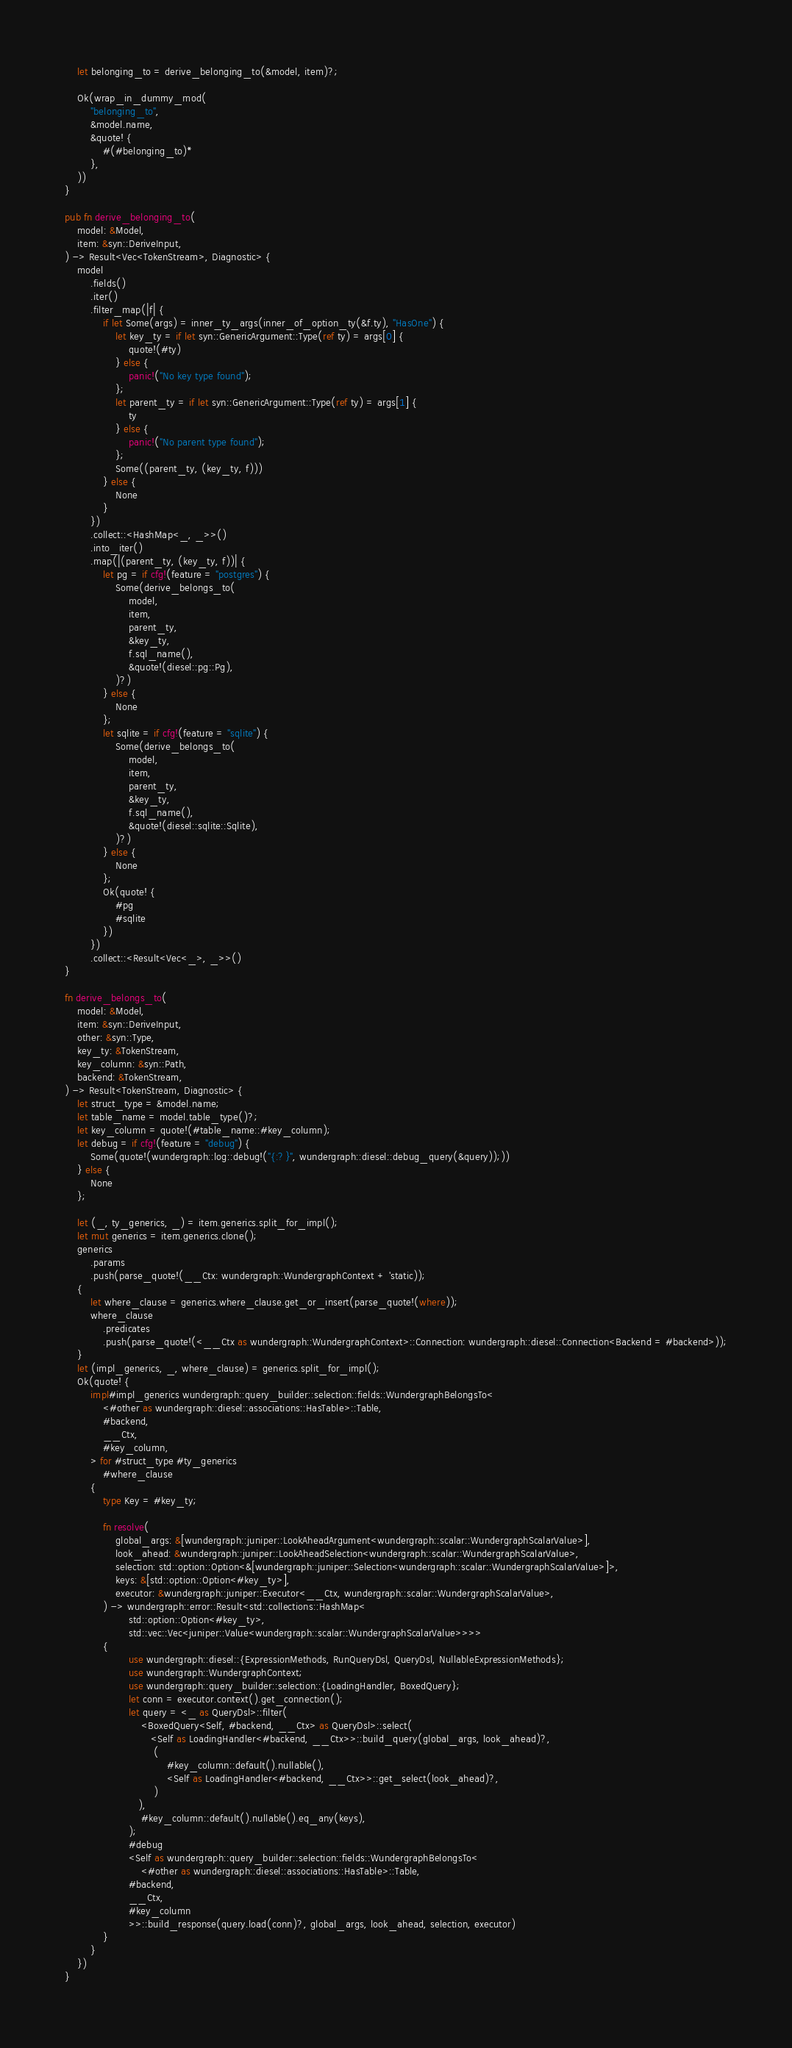Convert code to text. <code><loc_0><loc_0><loc_500><loc_500><_Rust_>    let belonging_to = derive_belonging_to(&model, item)?;

    Ok(wrap_in_dummy_mod(
        "belonging_to",
        &model.name,
        &quote! {
            #(#belonging_to)*
        },
    ))
}

pub fn derive_belonging_to(
    model: &Model,
    item: &syn::DeriveInput,
) -> Result<Vec<TokenStream>, Diagnostic> {
    model
        .fields()
        .iter()
        .filter_map(|f| {
            if let Some(args) = inner_ty_args(inner_of_option_ty(&f.ty), "HasOne") {
                let key_ty = if let syn::GenericArgument::Type(ref ty) = args[0] {
                    quote!(#ty)
                } else {
                    panic!("No key type found");
                };
                let parent_ty = if let syn::GenericArgument::Type(ref ty) = args[1] {
                    ty
                } else {
                    panic!("No parent type found");
                };
                Some((parent_ty, (key_ty, f)))
            } else {
                None
            }
        })
        .collect::<HashMap<_, _>>()
        .into_iter()
        .map(|(parent_ty, (key_ty, f))| {
            let pg = if cfg!(feature = "postgres") {
                Some(derive_belongs_to(
                    model,
                    item,
                    parent_ty,
                    &key_ty,
                    f.sql_name(),
                    &quote!(diesel::pg::Pg),
                )?)
            } else {
                None
            };
            let sqlite = if cfg!(feature = "sqlite") {
                Some(derive_belongs_to(
                    model,
                    item,
                    parent_ty,
                    &key_ty,
                    f.sql_name(),
                    &quote!(diesel::sqlite::Sqlite),
                )?)
            } else {
                None
            };
            Ok(quote! {
                #pg
                #sqlite
            })
        })
        .collect::<Result<Vec<_>, _>>()
}

fn derive_belongs_to(
    model: &Model,
    item: &syn::DeriveInput,
    other: &syn::Type,
    key_ty: &TokenStream,
    key_column: &syn::Path,
    backend: &TokenStream,
) -> Result<TokenStream, Diagnostic> {
    let struct_type = &model.name;
    let table_name = model.table_type()?;
    let key_column = quote!(#table_name::#key_column);
    let debug = if cfg!(feature = "debug") {
        Some(quote!(wundergraph::log::debug!("{:?}", wundergraph::diesel::debug_query(&query));))
    } else {
        None
    };

    let (_, ty_generics, _) = item.generics.split_for_impl();
    let mut generics = item.generics.clone();
    generics
        .params
        .push(parse_quote!(__Ctx: wundergraph::WundergraphContext + 'static));
    {
        let where_clause = generics.where_clause.get_or_insert(parse_quote!(where));
        where_clause
            .predicates
            .push(parse_quote!(<__Ctx as wundergraph::WundergraphContext>::Connection: wundergraph::diesel::Connection<Backend = #backend>));
    }
    let (impl_generics, _, where_clause) = generics.split_for_impl();
    Ok(quote! {
        impl#impl_generics wundergraph::query_builder::selection::fields::WundergraphBelongsTo<
            <#other as wundergraph::diesel::associations::HasTable>::Table,
            #backend,
            __Ctx,
            #key_column,
        > for #struct_type #ty_generics
            #where_clause
        {
            type Key = #key_ty;

            fn resolve(
                global_args: &[wundergraph::juniper::LookAheadArgument<wundergraph::scalar::WundergraphScalarValue>],
                look_ahead: &wundergraph::juniper::LookAheadSelection<wundergraph::scalar::WundergraphScalarValue>,
                selection: std::option::Option<&[wundergraph::juniper::Selection<wundergraph::scalar::WundergraphScalarValue>]>,
                keys: &[std::option::Option<#key_ty>],
                executor: &wundergraph::juniper::Executor<__Ctx, wundergraph::scalar::WundergraphScalarValue>,
            ) -> wundergraph::error::Result<std::collections::HashMap<
                    std::option::Option<#key_ty>,
                    std::vec::Vec<juniper::Value<wundergraph::scalar::WundergraphScalarValue>>>>
            {
                    use wundergraph::diesel::{ExpressionMethods, RunQueryDsl, QueryDsl, NullableExpressionMethods};
                    use wundergraph::WundergraphContext;
                    use wundergraph::query_builder::selection::{LoadingHandler, BoxedQuery};
                    let conn = executor.context().get_connection();
                    let query = <_ as QueryDsl>::filter(
                        <BoxedQuery<Self, #backend, __Ctx> as QueryDsl>::select(
                           <Self as LoadingHandler<#backend, __Ctx>>::build_query(global_args, look_ahead)?,
                            (
                                #key_column::default().nullable(),
                                <Self as LoadingHandler<#backend, __Ctx>>::get_select(look_ahead)?,
                            )
                       ),
                        #key_column::default().nullable().eq_any(keys),
                    );
                    #debug
                    <Self as wundergraph::query_builder::selection::fields::WundergraphBelongsTo<
                        <#other as wundergraph::diesel::associations::HasTable>::Table,
                    #backend,
                    __Ctx,
                    #key_column
                    >>::build_response(query.load(conn)?, global_args, look_ahead, selection, executor)
            }
        }
    })
}
</code> 